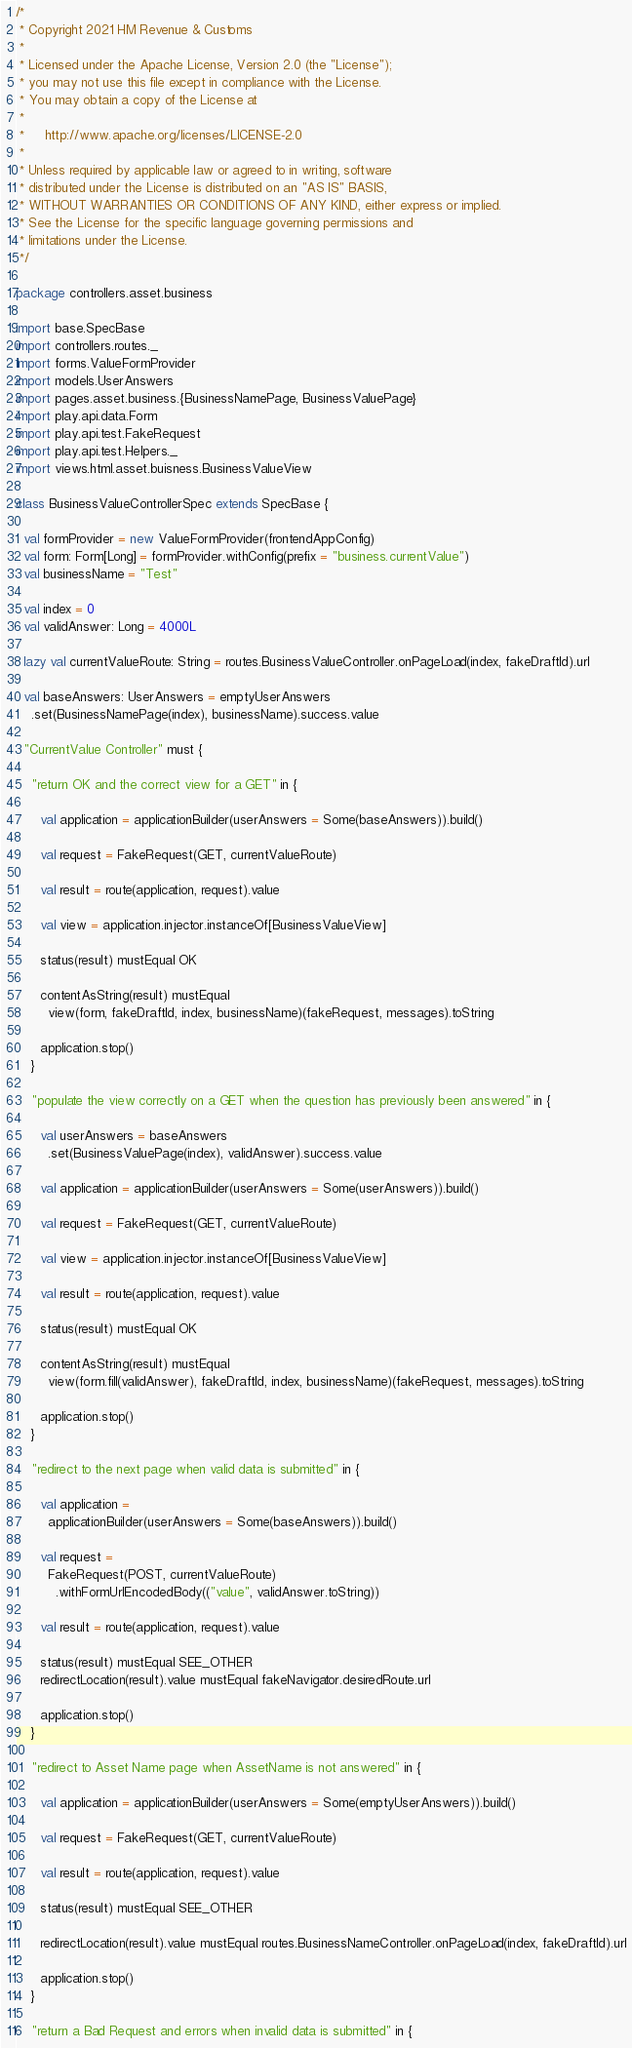Convert code to text. <code><loc_0><loc_0><loc_500><loc_500><_Scala_>/*
 * Copyright 2021 HM Revenue & Customs
 *
 * Licensed under the Apache License, Version 2.0 (the "License");
 * you may not use this file except in compliance with the License.
 * You may obtain a copy of the License at
 *
 *     http://www.apache.org/licenses/LICENSE-2.0
 *
 * Unless required by applicable law or agreed to in writing, software
 * distributed under the License is distributed on an "AS IS" BASIS,
 * WITHOUT WARRANTIES OR CONDITIONS OF ANY KIND, either express or implied.
 * See the License for the specific language governing permissions and
 * limitations under the License.
 */

package controllers.asset.business

import base.SpecBase
import controllers.routes._
import forms.ValueFormProvider
import models.UserAnswers
import pages.asset.business.{BusinessNamePage, BusinessValuePage}
import play.api.data.Form
import play.api.test.FakeRequest
import play.api.test.Helpers._
import views.html.asset.buisness.BusinessValueView

class BusinessValueControllerSpec extends SpecBase {

  val formProvider = new ValueFormProvider(frontendAppConfig)
  val form: Form[Long] = formProvider.withConfig(prefix = "business.currentValue")
  val businessName = "Test"

  val index = 0
  val validAnswer: Long = 4000L

  lazy val currentValueRoute: String = routes.BusinessValueController.onPageLoad(index, fakeDraftId).url

  val baseAnswers: UserAnswers = emptyUserAnswers
    .set(BusinessNamePage(index), businessName).success.value

  "CurrentValue Controller" must {

    "return OK and the correct view for a GET" in {

      val application = applicationBuilder(userAnswers = Some(baseAnswers)).build()

      val request = FakeRequest(GET, currentValueRoute)

      val result = route(application, request).value

      val view = application.injector.instanceOf[BusinessValueView]

      status(result) mustEqual OK

      contentAsString(result) mustEqual
        view(form, fakeDraftId, index, businessName)(fakeRequest, messages).toString

      application.stop()
    }

    "populate the view correctly on a GET when the question has previously been answered" in {

      val userAnswers = baseAnswers
        .set(BusinessValuePage(index), validAnswer).success.value

      val application = applicationBuilder(userAnswers = Some(userAnswers)).build()

      val request = FakeRequest(GET, currentValueRoute)

      val view = application.injector.instanceOf[BusinessValueView]

      val result = route(application, request).value

      status(result) mustEqual OK

      contentAsString(result) mustEqual
        view(form.fill(validAnswer), fakeDraftId, index, businessName)(fakeRequest, messages).toString

      application.stop()
    }

    "redirect to the next page when valid data is submitted" in {

      val application =
        applicationBuilder(userAnswers = Some(baseAnswers)).build()

      val request =
        FakeRequest(POST, currentValueRoute)
          .withFormUrlEncodedBody(("value", validAnswer.toString))

      val result = route(application, request).value

      status(result) mustEqual SEE_OTHER
      redirectLocation(result).value mustEqual fakeNavigator.desiredRoute.url

      application.stop()
    }

    "redirect to Asset Name page when AssetName is not answered" in {

      val application = applicationBuilder(userAnswers = Some(emptyUserAnswers)).build()

      val request = FakeRequest(GET, currentValueRoute)

      val result = route(application, request).value

      status(result) mustEqual SEE_OTHER

      redirectLocation(result).value mustEqual routes.BusinessNameController.onPageLoad(index, fakeDraftId).url

      application.stop()
    }

    "return a Bad Request and errors when invalid data is submitted" in {
</code> 